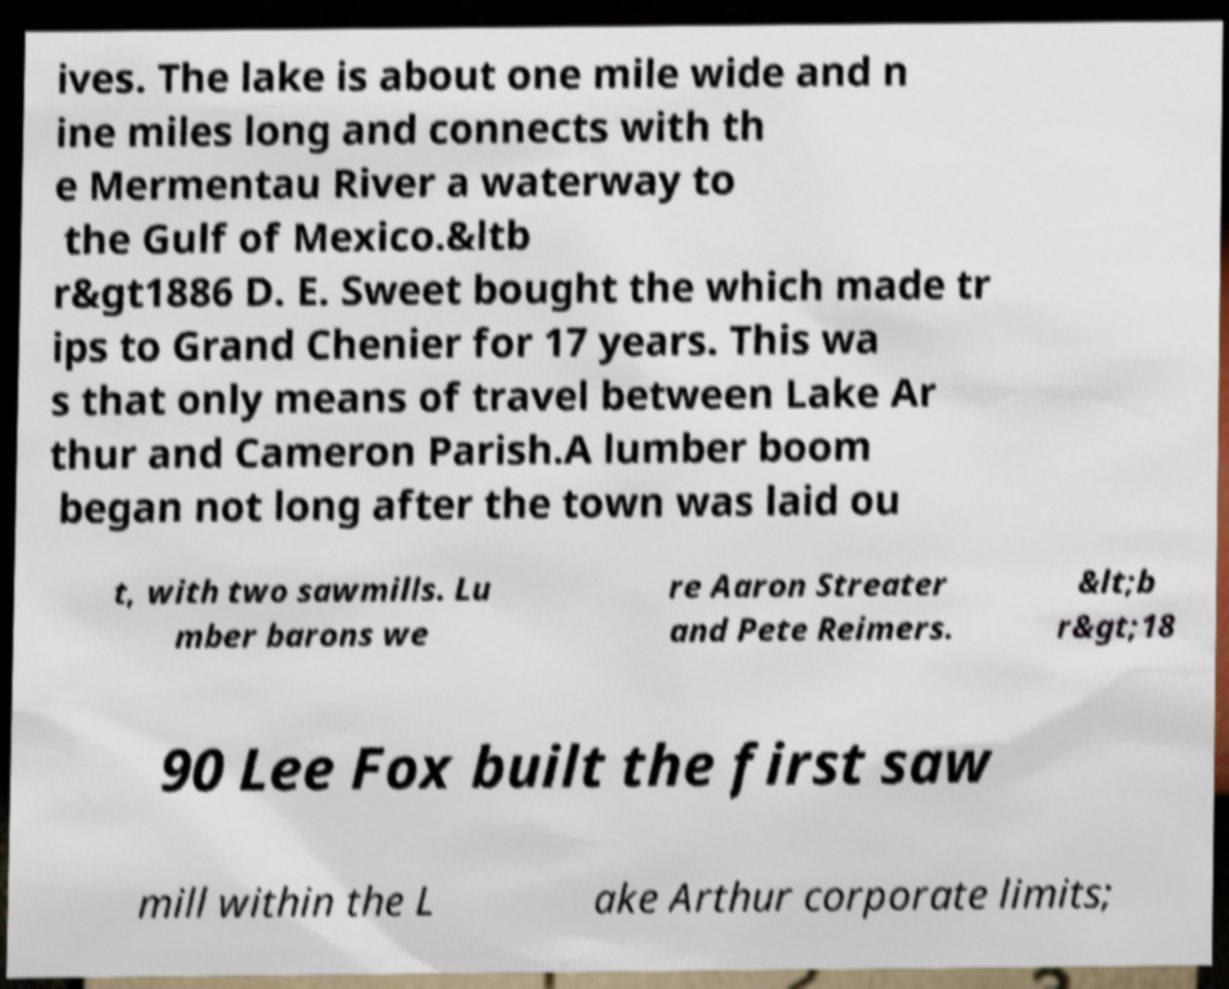Can you accurately transcribe the text from the provided image for me? ives. The lake is about one mile wide and n ine miles long and connects with th e Mermentau River a waterway to the Gulf of Mexico.&ltb r&gt1886 D. E. Sweet bought the which made tr ips to Grand Chenier for 17 years. This wa s that only means of travel between Lake Ar thur and Cameron Parish.A lumber boom began not long after the town was laid ou t, with two sawmills. Lu mber barons we re Aaron Streater and Pete Reimers. &lt;b r&gt;18 90 Lee Fox built the first saw mill within the L ake Arthur corporate limits; 